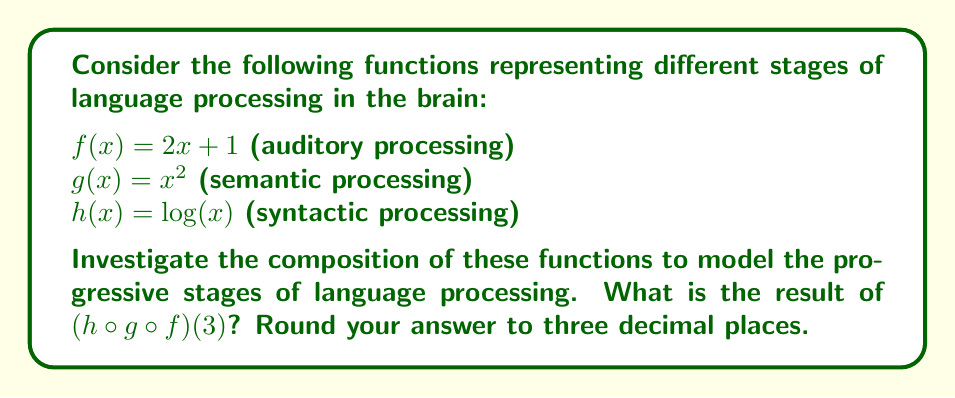Provide a solution to this math problem. To solve this problem, we need to apply the functions in the order specified by the composition, starting from the innermost function and working our way outward. Let's break it down step-by-step:

1) First, we apply $f(x) = 2x + 1$ to the input $x = 3$:
   $f(3) = 2(3) + 1 = 6 + 1 = 7$

2) Next, we take this result and apply $g(x) = x^2$:
   $g(f(3)) = g(7) = 7^2 = 49$

3) Finally, we apply $h(x) = \log(x)$ to this result:
   $h(g(f(3))) = h(49) = \log(49)$

4) Using a calculator or logarithm table, we can find that:
   $\log(49) \approx 3.8918$

5) Rounding to three decimal places:
   $3.8918 \approx 3.892$

This composition models how information might be processed through different stages in the brain during language comprehension:
- First, the auditory input is processed ($f$)
- Then, semantic meaning is extracted ($g$)
- Finally, syntactic structure is analyzed ($h$)

The result represents the cumulative effect of these processing stages on the initial input.
Answer: $(h \circ g \circ f)(3) \approx 3.892$ 